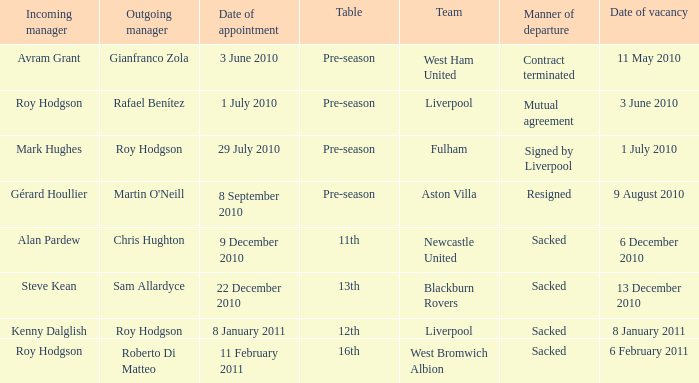What is the date of vacancy for the Liverpool team with a table named pre-season? 3 June 2010. 